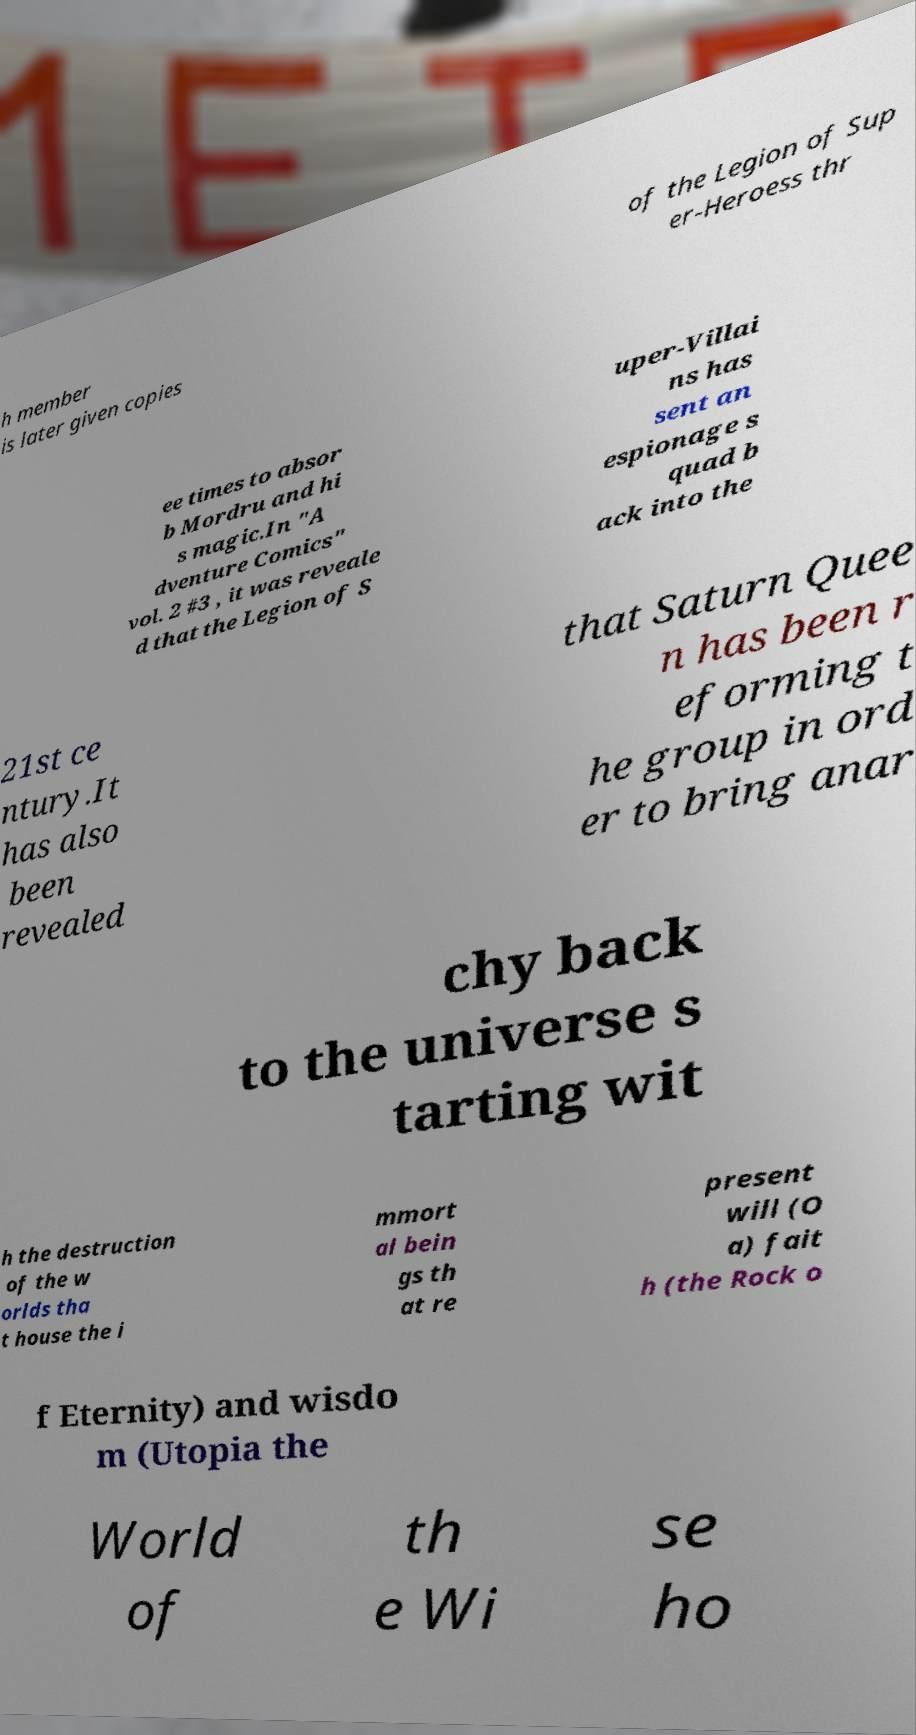Can you accurately transcribe the text from the provided image for me? h member is later given copies of the Legion of Sup er-Heroess thr ee times to absor b Mordru and hi s magic.In "A dventure Comics" vol. 2 #3 , it was reveale d that the Legion of S uper-Villai ns has sent an espionage s quad b ack into the 21st ce ntury.It has also been revealed that Saturn Quee n has been r eforming t he group in ord er to bring anar chy back to the universe s tarting wit h the destruction of the w orlds tha t house the i mmort al bein gs th at re present will (O a) fait h (the Rock o f Eternity) and wisdo m (Utopia the World of th e Wi se ho 